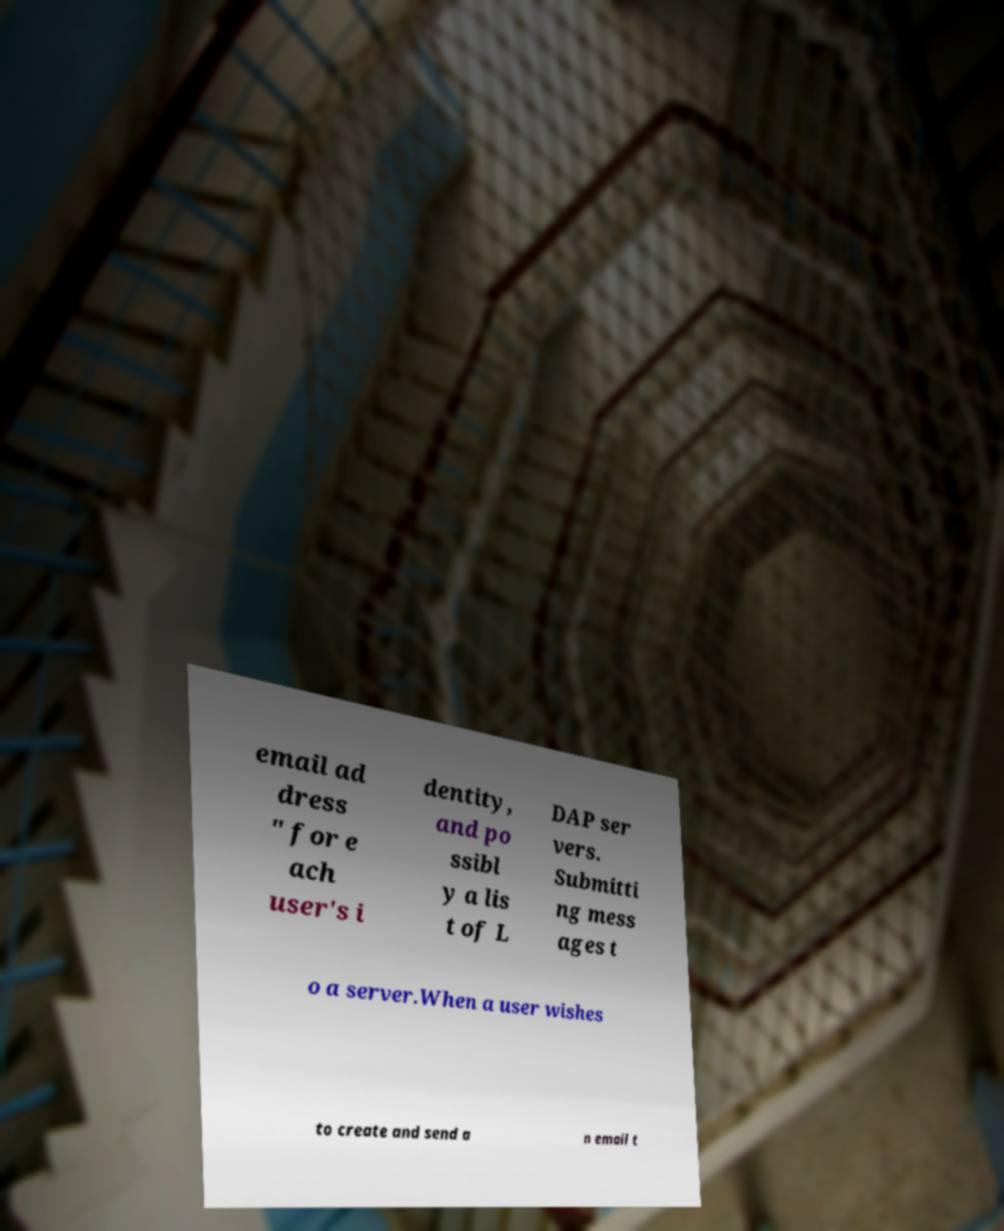Could you assist in decoding the text presented in this image and type it out clearly? email ad dress " for e ach user's i dentity, and po ssibl y a lis t of L DAP ser vers. Submitti ng mess ages t o a server.When a user wishes to create and send a n email t 